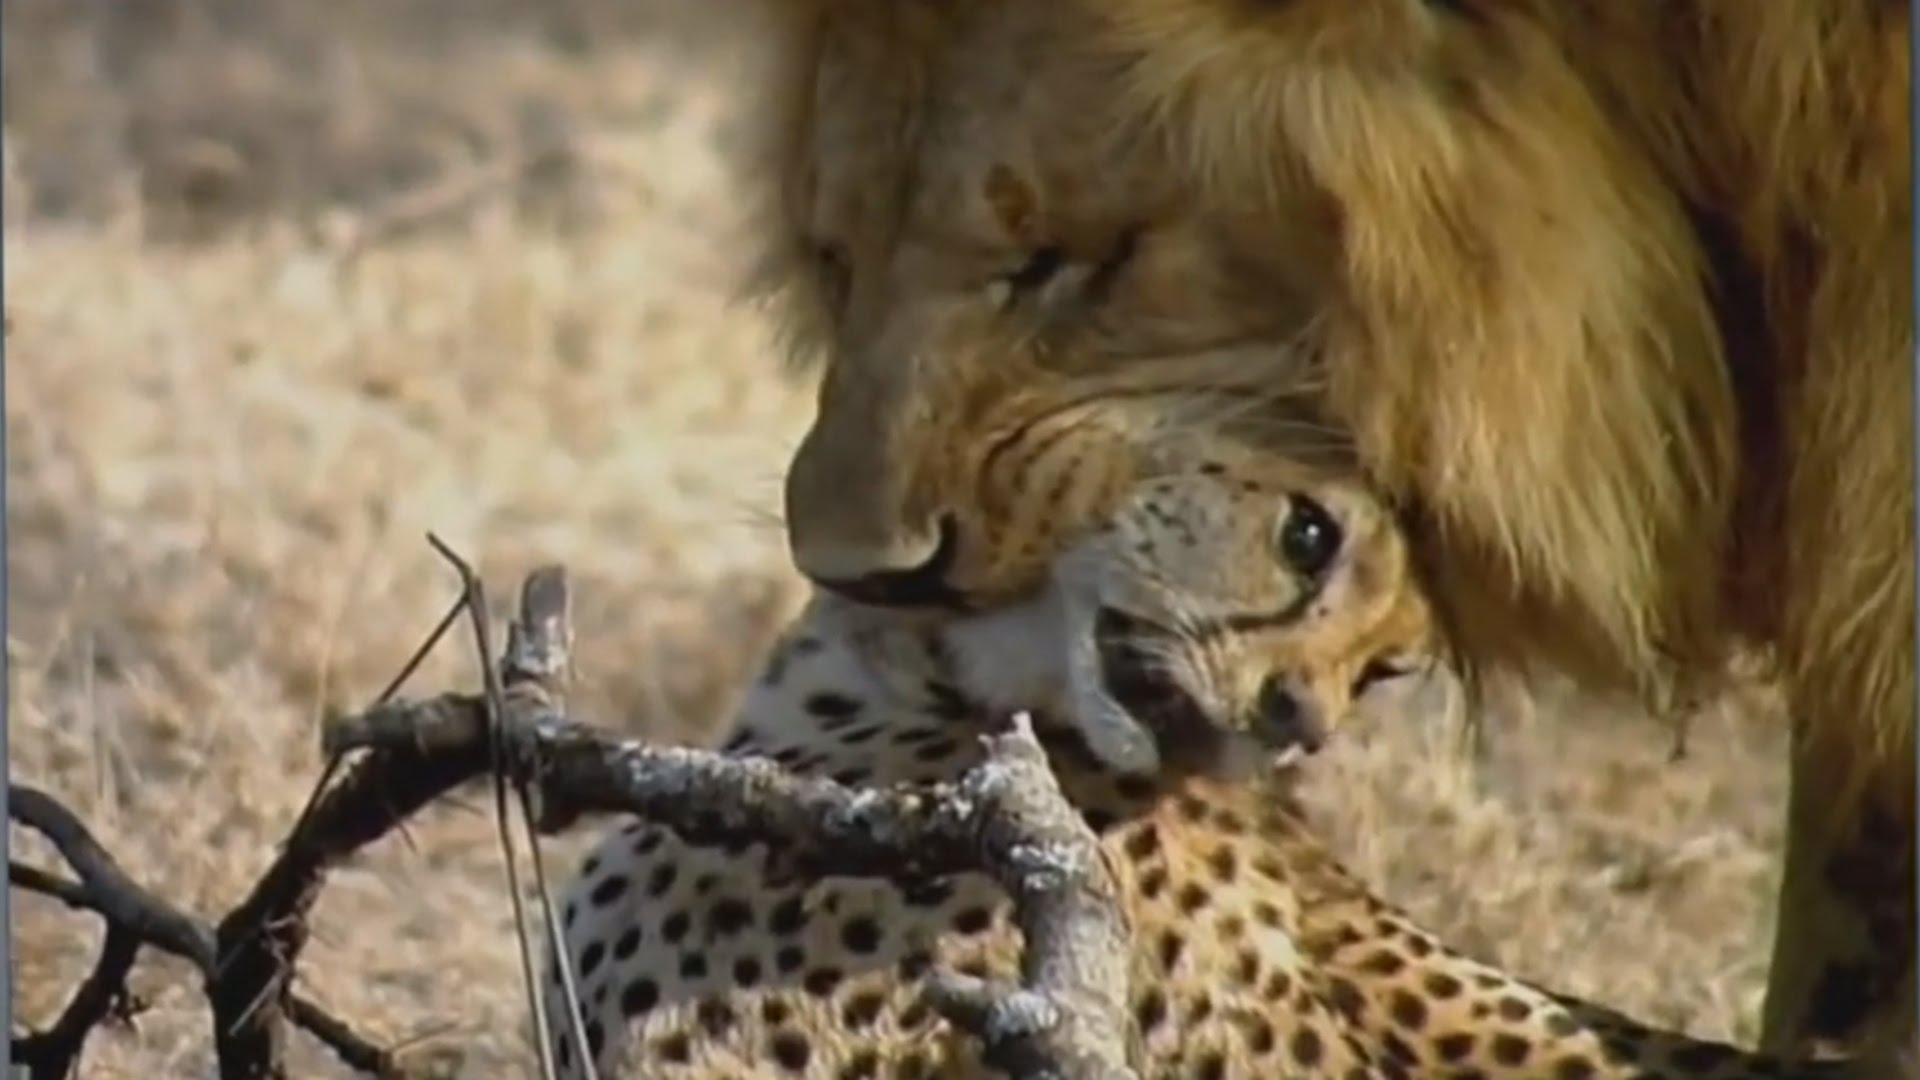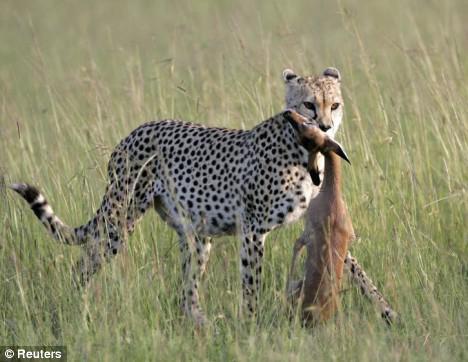The first image is the image on the left, the second image is the image on the right. Given the left and right images, does the statement "contains a picture of a cheetah carrying its food" hold true? Answer yes or no. Yes. The first image is the image on the left, the second image is the image on the right. For the images displayed, is the sentence "One image shows two cheetahs posing non-agressively with a small deerlike animal, and the other shows a cheetah with its prey grasped in its jaw." factually correct? Answer yes or no. No. 